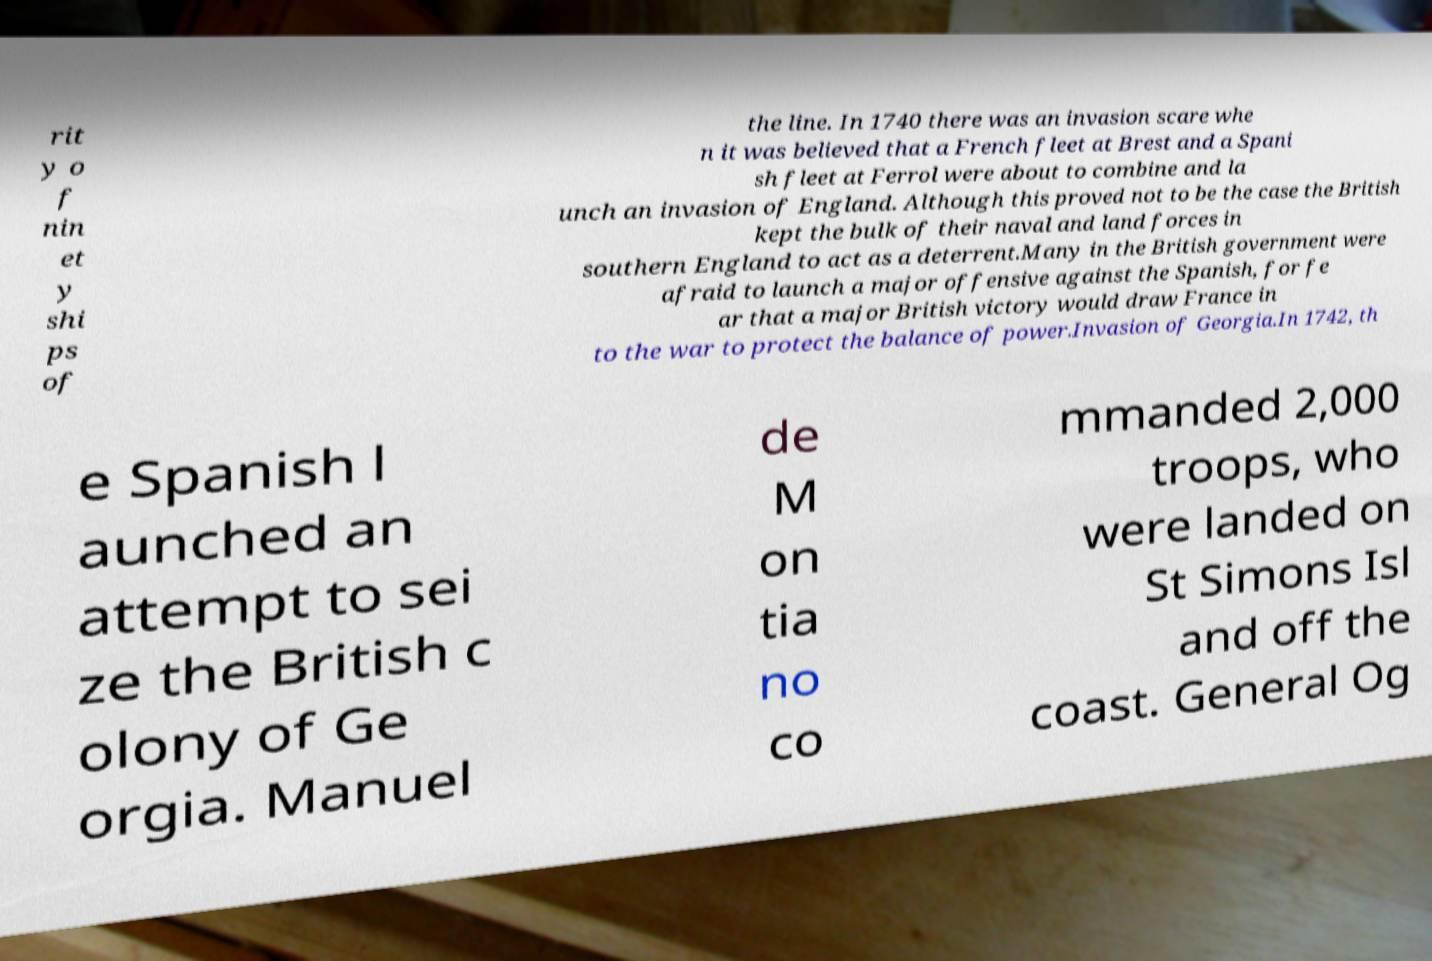Can you accurately transcribe the text from the provided image for me? rit y o f nin et y shi ps of the line. In 1740 there was an invasion scare whe n it was believed that a French fleet at Brest and a Spani sh fleet at Ferrol were about to combine and la unch an invasion of England. Although this proved not to be the case the British kept the bulk of their naval and land forces in southern England to act as a deterrent.Many in the British government were afraid to launch a major offensive against the Spanish, for fe ar that a major British victory would draw France in to the war to protect the balance of power.Invasion of Georgia.In 1742, th e Spanish l aunched an attempt to sei ze the British c olony of Ge orgia. Manuel de M on tia no co mmanded 2,000 troops, who were landed on St Simons Isl and off the coast. General Og 